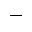<formula> <loc_0><loc_0><loc_500><loc_500>-</formula> 